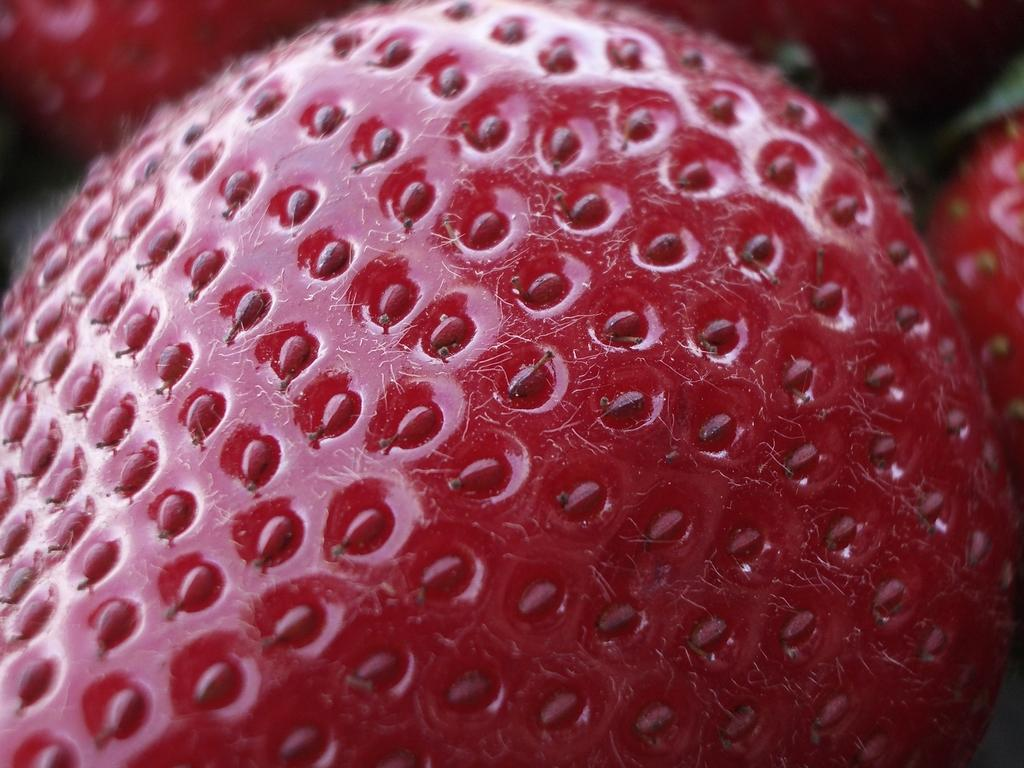What type of fruit is present in the image? There is a strawberry in the image. Can you see any writing on the strawberry in the image? There is no writing present on the strawberry in the image. 